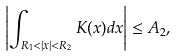Convert formula to latex. <formula><loc_0><loc_0><loc_500><loc_500>\left | \int _ { R _ { 1 } < | x | < R _ { 2 } } K ( x ) d x \right | \leq A _ { 2 } ,</formula> 